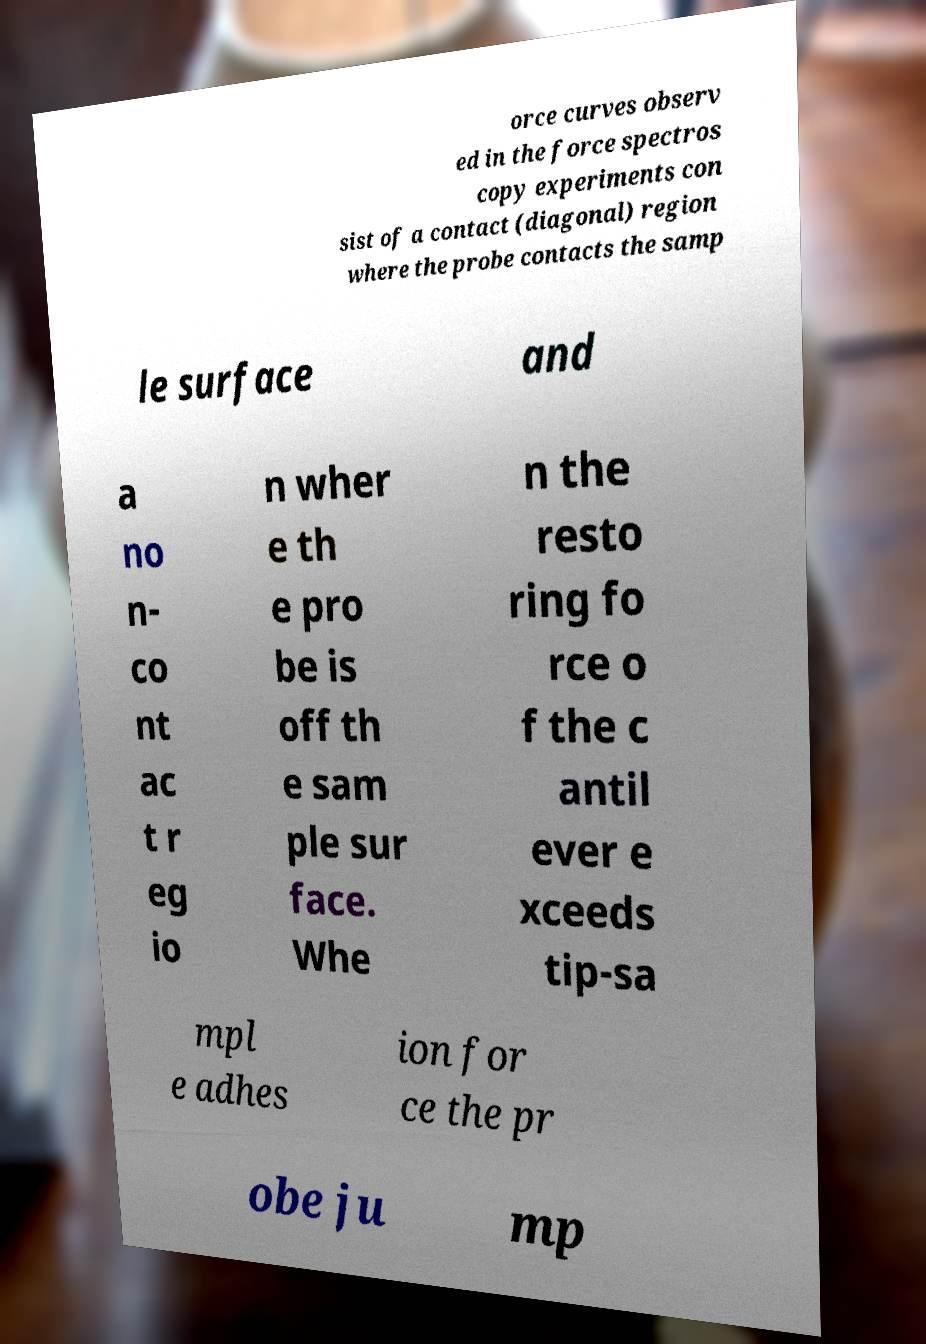For documentation purposes, I need the text within this image transcribed. Could you provide that? orce curves observ ed in the force spectros copy experiments con sist of a contact (diagonal) region where the probe contacts the samp le surface and a no n- co nt ac t r eg io n wher e th e pro be is off th e sam ple sur face. Whe n the resto ring fo rce o f the c antil ever e xceeds tip-sa mpl e adhes ion for ce the pr obe ju mp 